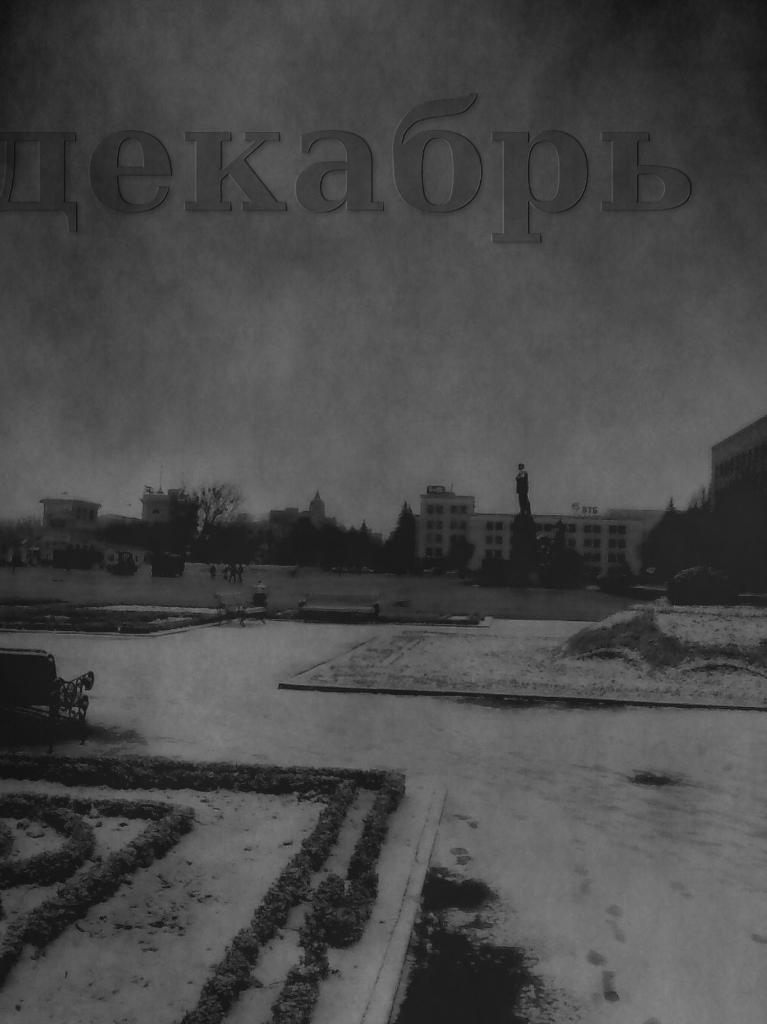Please provide a concise description of this image. This is a black and white image. We can see the buildings, trees and a statue. On the left side of the image, there are benches, grass and it looks like the snow. Behind the buildings, there is the sky. At the top of the image, there is a watermark. 